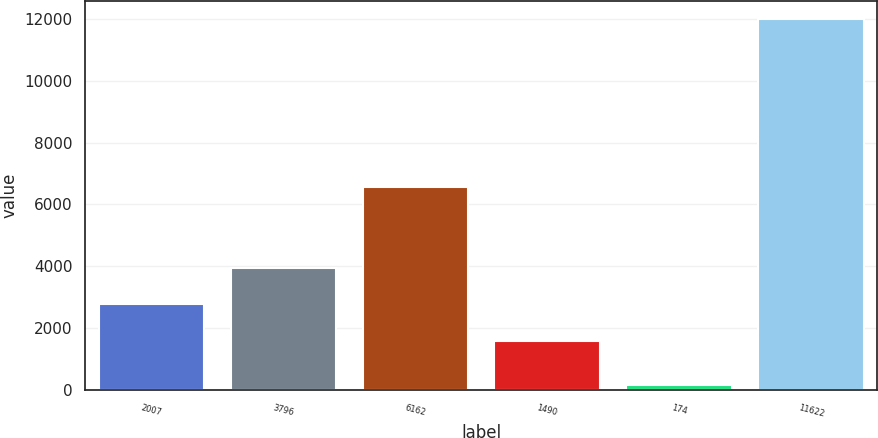Convert chart to OTSL. <chart><loc_0><loc_0><loc_500><loc_500><bar_chart><fcel>2007<fcel>3796<fcel>6162<fcel>1490<fcel>174<fcel>11622<nl><fcel>2769.8<fcel>3951.6<fcel>6573<fcel>1588<fcel>170<fcel>11988<nl></chart> 